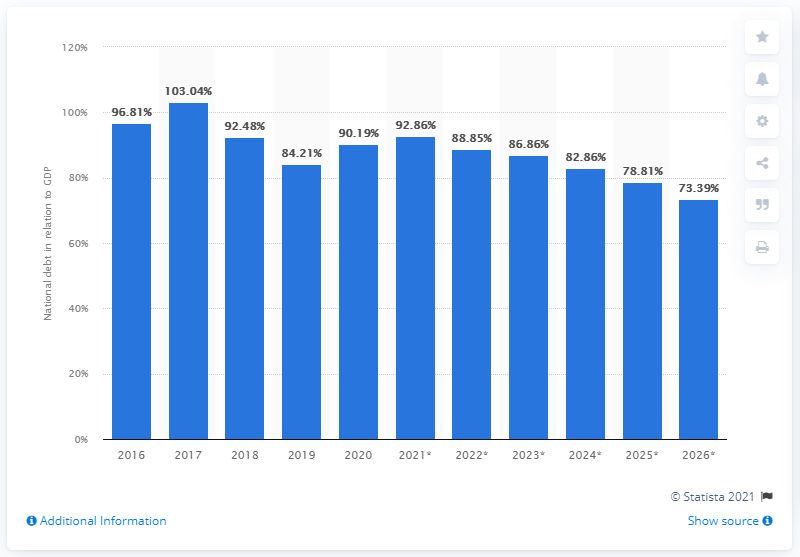Identify some key points in this picture. In 2020, Egypt's national debt accounted for approximately 90.19% of its GDP. In 2020, Egypt's national debt came to an end. 